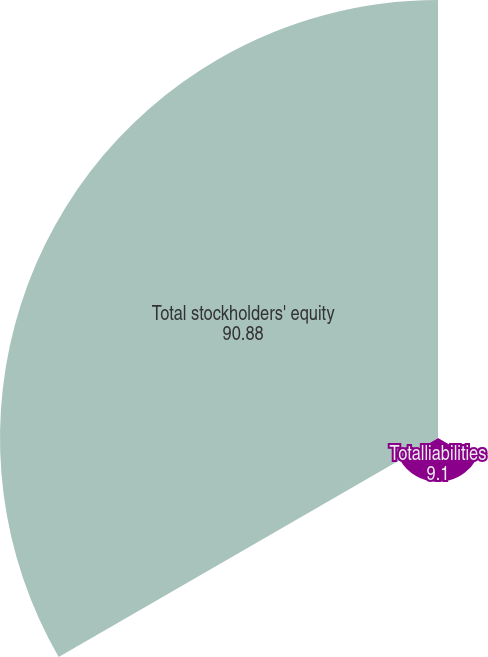Convert chart to OTSL. <chart><loc_0><loc_0><loc_500><loc_500><pie_chart><fcel>Accounts payable and other<fcel>Totalliabilities<fcel>Total stockholders' equity<nl><fcel>0.02%<fcel>9.1%<fcel>90.88%<nl></chart> 